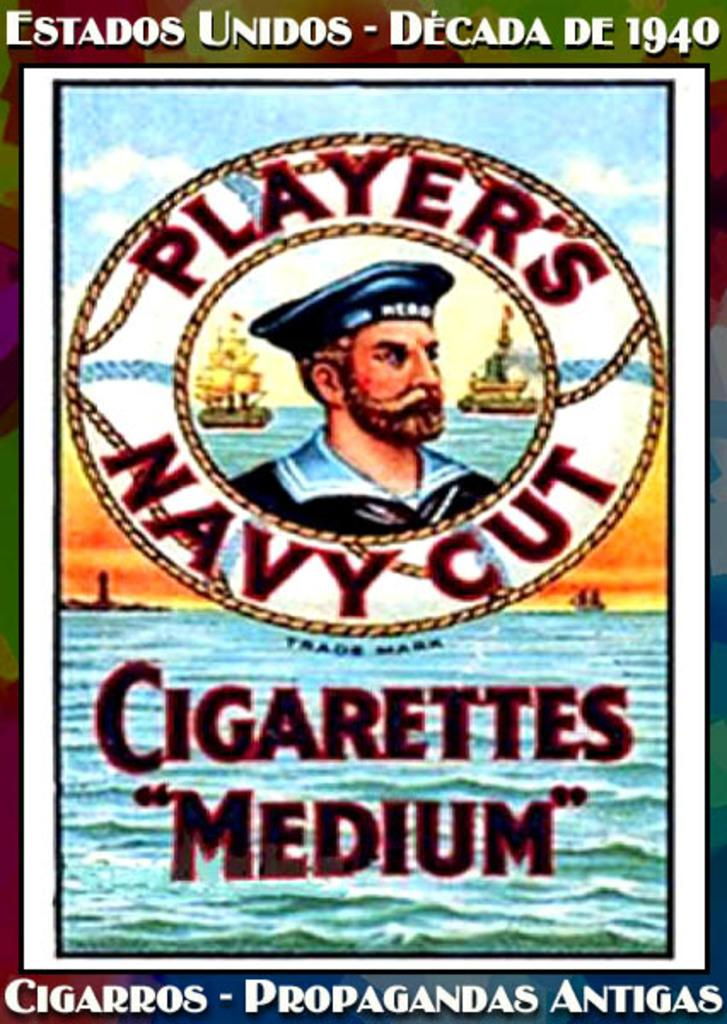<image>
Present a compact description of the photo's key features. A vintage Player's Navy Cut medium cigarettes advertisement. 